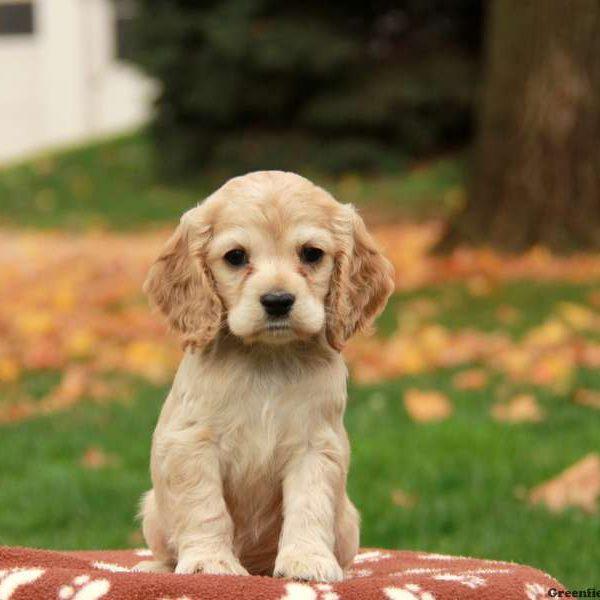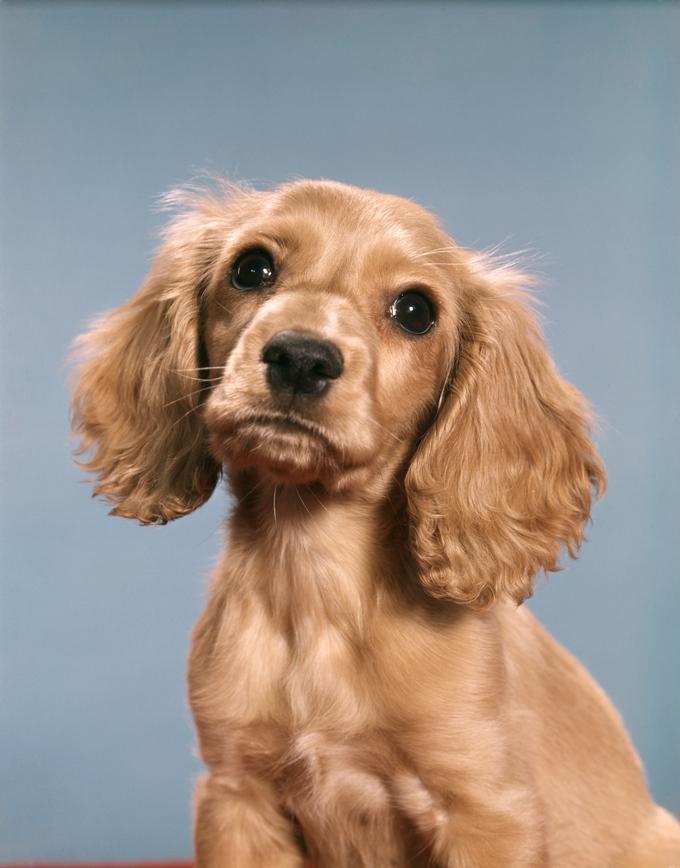The first image is the image on the left, the second image is the image on the right. Given the left and right images, does the statement "One of the dogs is near the grass." hold true? Answer yes or no. Yes. 